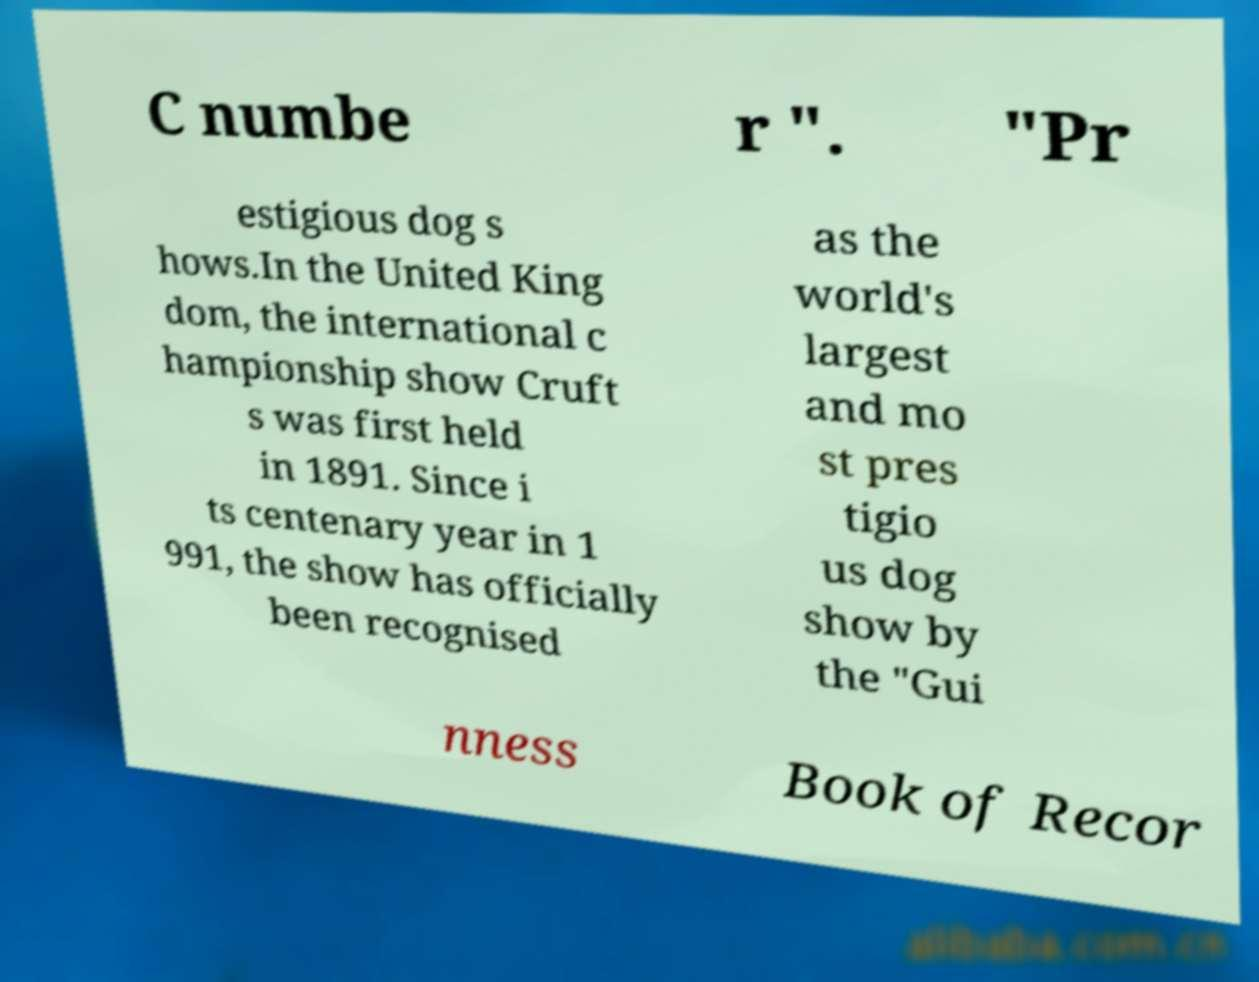Can you accurately transcribe the text from the provided image for me? C numbe r ". "Pr estigious dog s hows.In the United King dom, the international c hampionship show Cruft s was first held in 1891. Since i ts centenary year in 1 991, the show has officially been recognised as the world's largest and mo st pres tigio us dog show by the "Gui nness Book of Recor 